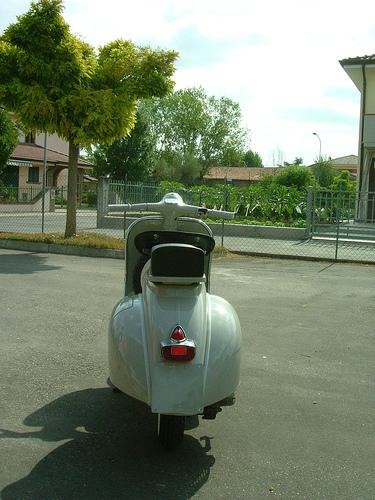Describe the setting in which the scooter is placed. The scooter is parked on a quiet residential street, lined with well-kept houses and lush greenery. It gives off a serene and peaceful suburban vibe, inviting a leisurely ride around the neighborhood. 